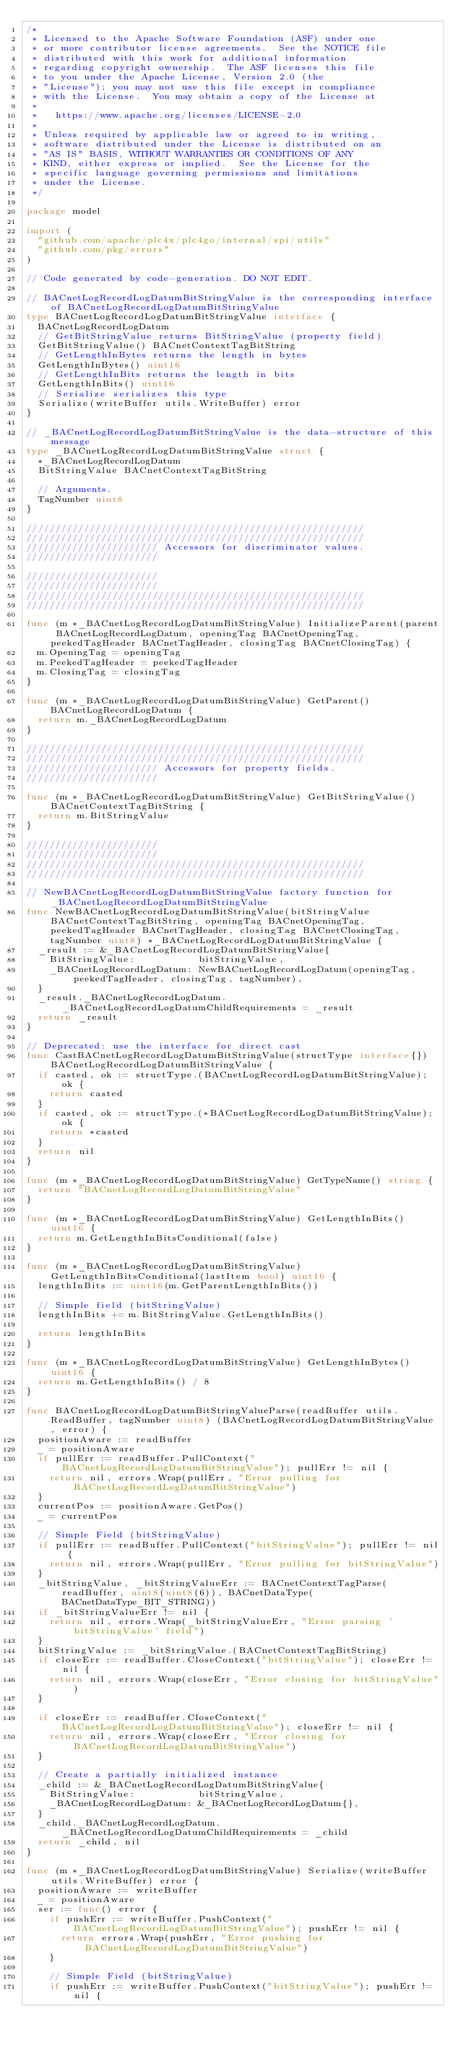Convert code to text. <code><loc_0><loc_0><loc_500><loc_500><_Go_>/*
 * Licensed to the Apache Software Foundation (ASF) under one
 * or more contributor license agreements.  See the NOTICE file
 * distributed with this work for additional information
 * regarding copyright ownership.  The ASF licenses this file
 * to you under the Apache License, Version 2.0 (the
 * "License"); you may not use this file except in compliance
 * with the License.  You may obtain a copy of the License at
 *
 *   https://www.apache.org/licenses/LICENSE-2.0
 *
 * Unless required by applicable law or agreed to in writing,
 * software distributed under the License is distributed on an
 * "AS IS" BASIS, WITHOUT WARRANTIES OR CONDITIONS OF ANY
 * KIND, either express or implied.  See the License for the
 * specific language governing permissions and limitations
 * under the License.
 */

package model

import (
	"github.com/apache/plc4x/plc4go/internal/spi/utils"
	"github.com/pkg/errors"
)

// Code generated by code-generation. DO NOT EDIT.

// BACnetLogRecordLogDatumBitStringValue is the corresponding interface of BACnetLogRecordLogDatumBitStringValue
type BACnetLogRecordLogDatumBitStringValue interface {
	BACnetLogRecordLogDatum
	// GetBitStringValue returns BitStringValue (property field)
	GetBitStringValue() BACnetContextTagBitString
	// GetLengthInBytes returns the length in bytes
	GetLengthInBytes() uint16
	// GetLengthInBits returns the length in bits
	GetLengthInBits() uint16
	// Serialize serializes this type
	Serialize(writeBuffer utils.WriteBuffer) error
}

// _BACnetLogRecordLogDatumBitStringValue is the data-structure of this message
type _BACnetLogRecordLogDatumBitStringValue struct {
	*_BACnetLogRecordLogDatum
	BitStringValue BACnetContextTagBitString

	// Arguments.
	TagNumber uint8
}

///////////////////////////////////////////////////////////
///////////////////////////////////////////////////////////
/////////////////////// Accessors for discriminator values.
///////////////////////

///////////////////////
///////////////////////
///////////////////////////////////////////////////////////
///////////////////////////////////////////////////////////

func (m *_BACnetLogRecordLogDatumBitStringValue) InitializeParent(parent BACnetLogRecordLogDatum, openingTag BACnetOpeningTag, peekedTagHeader BACnetTagHeader, closingTag BACnetClosingTag) {
	m.OpeningTag = openingTag
	m.PeekedTagHeader = peekedTagHeader
	m.ClosingTag = closingTag
}

func (m *_BACnetLogRecordLogDatumBitStringValue) GetParent() BACnetLogRecordLogDatum {
	return m._BACnetLogRecordLogDatum
}

///////////////////////////////////////////////////////////
///////////////////////////////////////////////////////////
/////////////////////// Accessors for property fields.
///////////////////////

func (m *_BACnetLogRecordLogDatumBitStringValue) GetBitStringValue() BACnetContextTagBitString {
	return m.BitStringValue
}

///////////////////////
///////////////////////
///////////////////////////////////////////////////////////
///////////////////////////////////////////////////////////

// NewBACnetLogRecordLogDatumBitStringValue factory function for _BACnetLogRecordLogDatumBitStringValue
func NewBACnetLogRecordLogDatumBitStringValue(bitStringValue BACnetContextTagBitString, openingTag BACnetOpeningTag, peekedTagHeader BACnetTagHeader, closingTag BACnetClosingTag, tagNumber uint8) *_BACnetLogRecordLogDatumBitStringValue {
	_result := &_BACnetLogRecordLogDatumBitStringValue{
		BitStringValue:           bitStringValue,
		_BACnetLogRecordLogDatum: NewBACnetLogRecordLogDatum(openingTag, peekedTagHeader, closingTag, tagNumber),
	}
	_result._BACnetLogRecordLogDatum._BACnetLogRecordLogDatumChildRequirements = _result
	return _result
}

// Deprecated: use the interface for direct cast
func CastBACnetLogRecordLogDatumBitStringValue(structType interface{}) BACnetLogRecordLogDatumBitStringValue {
	if casted, ok := structType.(BACnetLogRecordLogDatumBitStringValue); ok {
		return casted
	}
	if casted, ok := structType.(*BACnetLogRecordLogDatumBitStringValue); ok {
		return *casted
	}
	return nil
}

func (m *_BACnetLogRecordLogDatumBitStringValue) GetTypeName() string {
	return "BACnetLogRecordLogDatumBitStringValue"
}

func (m *_BACnetLogRecordLogDatumBitStringValue) GetLengthInBits() uint16 {
	return m.GetLengthInBitsConditional(false)
}

func (m *_BACnetLogRecordLogDatumBitStringValue) GetLengthInBitsConditional(lastItem bool) uint16 {
	lengthInBits := uint16(m.GetParentLengthInBits())

	// Simple field (bitStringValue)
	lengthInBits += m.BitStringValue.GetLengthInBits()

	return lengthInBits
}

func (m *_BACnetLogRecordLogDatumBitStringValue) GetLengthInBytes() uint16 {
	return m.GetLengthInBits() / 8
}

func BACnetLogRecordLogDatumBitStringValueParse(readBuffer utils.ReadBuffer, tagNumber uint8) (BACnetLogRecordLogDatumBitStringValue, error) {
	positionAware := readBuffer
	_ = positionAware
	if pullErr := readBuffer.PullContext("BACnetLogRecordLogDatumBitStringValue"); pullErr != nil {
		return nil, errors.Wrap(pullErr, "Error pulling for BACnetLogRecordLogDatumBitStringValue")
	}
	currentPos := positionAware.GetPos()
	_ = currentPos

	// Simple Field (bitStringValue)
	if pullErr := readBuffer.PullContext("bitStringValue"); pullErr != nil {
		return nil, errors.Wrap(pullErr, "Error pulling for bitStringValue")
	}
	_bitStringValue, _bitStringValueErr := BACnetContextTagParse(readBuffer, uint8(uint8(6)), BACnetDataType(BACnetDataType_BIT_STRING))
	if _bitStringValueErr != nil {
		return nil, errors.Wrap(_bitStringValueErr, "Error parsing 'bitStringValue' field")
	}
	bitStringValue := _bitStringValue.(BACnetContextTagBitString)
	if closeErr := readBuffer.CloseContext("bitStringValue"); closeErr != nil {
		return nil, errors.Wrap(closeErr, "Error closing for bitStringValue")
	}

	if closeErr := readBuffer.CloseContext("BACnetLogRecordLogDatumBitStringValue"); closeErr != nil {
		return nil, errors.Wrap(closeErr, "Error closing for BACnetLogRecordLogDatumBitStringValue")
	}

	// Create a partially initialized instance
	_child := &_BACnetLogRecordLogDatumBitStringValue{
		BitStringValue:           bitStringValue,
		_BACnetLogRecordLogDatum: &_BACnetLogRecordLogDatum{},
	}
	_child._BACnetLogRecordLogDatum._BACnetLogRecordLogDatumChildRequirements = _child
	return _child, nil
}

func (m *_BACnetLogRecordLogDatumBitStringValue) Serialize(writeBuffer utils.WriteBuffer) error {
	positionAware := writeBuffer
	_ = positionAware
	ser := func() error {
		if pushErr := writeBuffer.PushContext("BACnetLogRecordLogDatumBitStringValue"); pushErr != nil {
			return errors.Wrap(pushErr, "Error pushing for BACnetLogRecordLogDatumBitStringValue")
		}

		// Simple Field (bitStringValue)
		if pushErr := writeBuffer.PushContext("bitStringValue"); pushErr != nil {</code> 